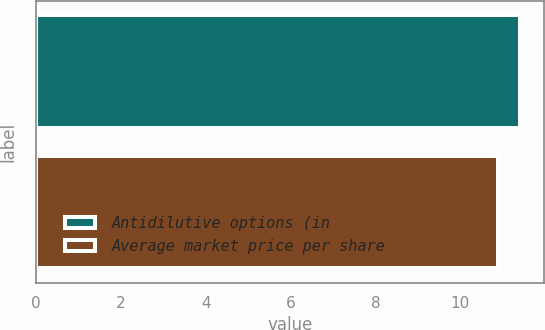<chart> <loc_0><loc_0><loc_500><loc_500><bar_chart><fcel>Antidilutive options (in<fcel>Average market price per share<nl><fcel>11.4<fcel>10.88<nl></chart> 